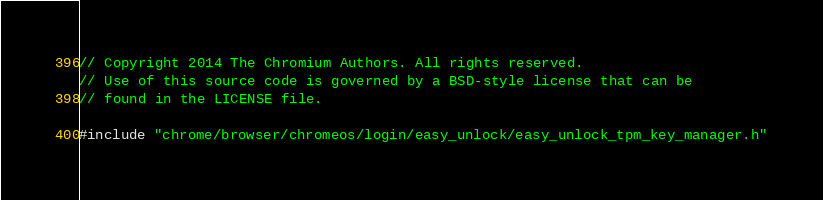Convert code to text. <code><loc_0><loc_0><loc_500><loc_500><_C++_>// Copyright 2014 The Chromium Authors. All rights reserved.
// Use of this source code is governed by a BSD-style license that can be
// found in the LICENSE file.

#include "chrome/browser/chromeos/login/easy_unlock/easy_unlock_tpm_key_manager.h"
</code> 